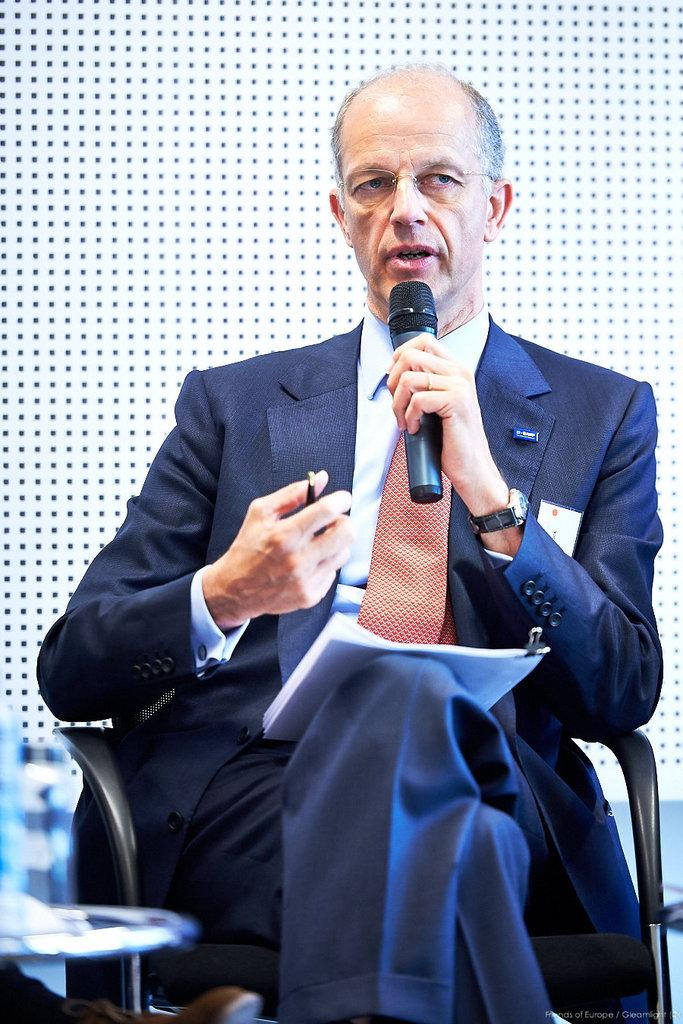What is the person in the image wearing? The person is wearing a blue suit. What is the person holding in the image? The person is holding a microphone. What is the person doing in the image? The person is talking. What accessories does the person have in the image? The person is wearing a watch and spectacles. What tools does the person have for writing in the image? The person has a paper and pen. What is the person sitting on in the image? The person is sitting on a chair. How many women are present in the image? The image only shows one person, and there is no indication of their gender. Therefore, we cannot determine the number of women in the image. 